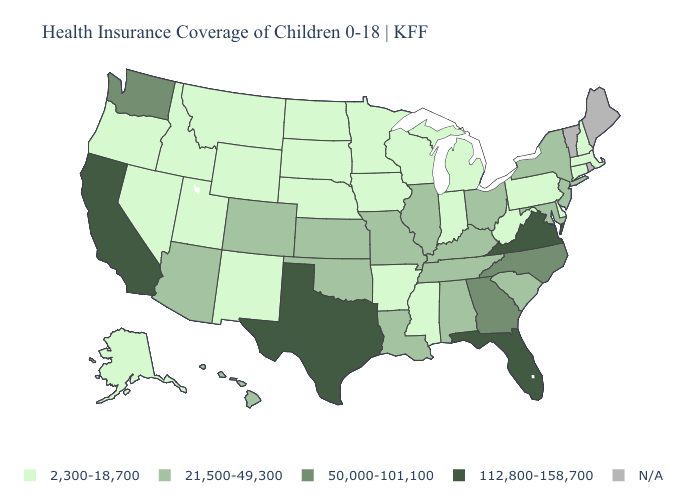What is the value of New Mexico?
Short answer required. 2,300-18,700. Which states hav the highest value in the West?
Keep it brief. California. Name the states that have a value in the range 112,800-158,700?
Keep it brief. California, Florida, Texas, Virginia. What is the value of Illinois?
Give a very brief answer. 21,500-49,300. What is the value of South Carolina?
Quick response, please. 21,500-49,300. Among the states that border Missouri , which have the highest value?
Give a very brief answer. Illinois, Kansas, Kentucky, Oklahoma, Tennessee. Is the legend a continuous bar?
Concise answer only. No. Name the states that have a value in the range 50,000-101,100?
Write a very short answer. Georgia, North Carolina, Washington. Name the states that have a value in the range 50,000-101,100?
Answer briefly. Georgia, North Carolina, Washington. What is the value of Hawaii?
Give a very brief answer. 21,500-49,300. Which states have the lowest value in the USA?
Short answer required. Alaska, Arkansas, Connecticut, Delaware, Idaho, Indiana, Iowa, Massachusetts, Michigan, Minnesota, Mississippi, Montana, Nebraska, Nevada, New Hampshire, New Mexico, North Dakota, Oregon, Pennsylvania, South Dakota, Utah, West Virginia, Wisconsin, Wyoming. Does the map have missing data?
Answer briefly. Yes. What is the value of Iowa?
Keep it brief. 2,300-18,700. Among the states that border Georgia , which have the highest value?
Short answer required. Florida. 